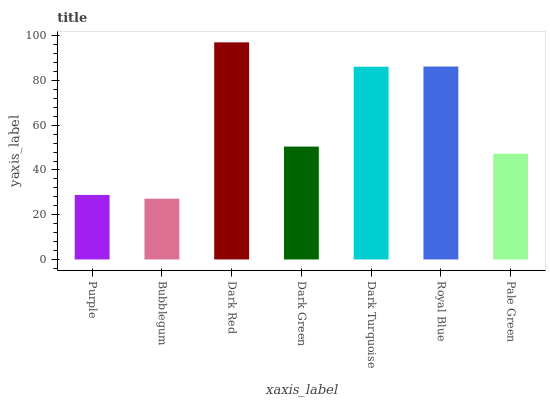Is Bubblegum the minimum?
Answer yes or no. Yes. Is Dark Red the maximum?
Answer yes or no. Yes. Is Dark Red the minimum?
Answer yes or no. No. Is Bubblegum the maximum?
Answer yes or no. No. Is Dark Red greater than Bubblegum?
Answer yes or no. Yes. Is Bubblegum less than Dark Red?
Answer yes or no. Yes. Is Bubblegum greater than Dark Red?
Answer yes or no. No. Is Dark Red less than Bubblegum?
Answer yes or no. No. Is Dark Green the high median?
Answer yes or no. Yes. Is Dark Green the low median?
Answer yes or no. Yes. Is Dark Turquoise the high median?
Answer yes or no. No. Is Bubblegum the low median?
Answer yes or no. No. 